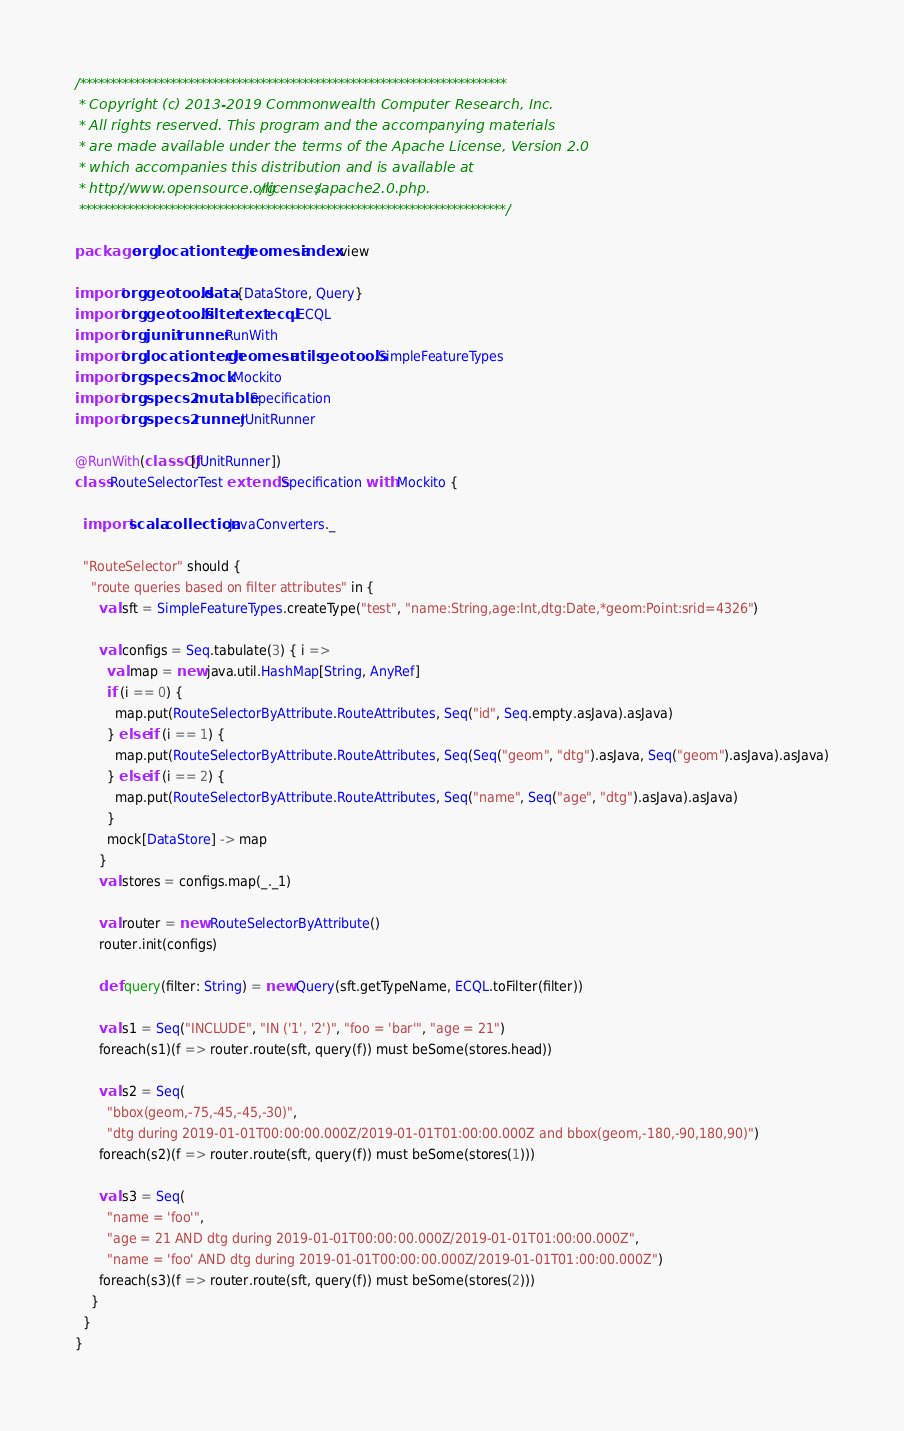<code> <loc_0><loc_0><loc_500><loc_500><_Scala_>/***********************************************************************
 * Copyright (c) 2013-2019 Commonwealth Computer Research, Inc.
 * All rights reserved. This program and the accompanying materials
 * are made available under the terms of the Apache License, Version 2.0
 * which accompanies this distribution and is available at
 * http://www.opensource.org/licenses/apache2.0.php.
 ***********************************************************************/

package org.locationtech.geomesa.index.view

import org.geotools.data.{DataStore, Query}
import org.geotools.filter.text.ecql.ECQL
import org.junit.runner.RunWith
import org.locationtech.geomesa.utils.geotools.SimpleFeatureTypes
import org.specs2.mock.Mockito
import org.specs2.mutable.Specification
import org.specs2.runner.JUnitRunner

@RunWith(classOf[JUnitRunner])
class RouteSelectorTest extends Specification with Mockito {

  import scala.collection.JavaConverters._

  "RouteSelector" should {
    "route queries based on filter attributes" in {
      val sft = SimpleFeatureTypes.createType("test", "name:String,age:Int,dtg:Date,*geom:Point:srid=4326")

      val configs = Seq.tabulate(3) { i =>
        val map = new java.util.HashMap[String, AnyRef]
        if (i == 0) {
          map.put(RouteSelectorByAttribute.RouteAttributes, Seq("id", Seq.empty.asJava).asJava)
        } else if (i == 1) {
          map.put(RouteSelectorByAttribute.RouteAttributes, Seq(Seq("geom", "dtg").asJava, Seq("geom").asJava).asJava)
        } else if (i == 2) {
          map.put(RouteSelectorByAttribute.RouteAttributes, Seq("name", Seq("age", "dtg").asJava).asJava)
        }
        mock[DataStore] -> map
      }
      val stores = configs.map(_._1)

      val router = new RouteSelectorByAttribute()
      router.init(configs)

      def query(filter: String) = new Query(sft.getTypeName, ECQL.toFilter(filter))

      val s1 = Seq("INCLUDE", "IN ('1', '2')", "foo = 'bar'", "age = 21")
      foreach(s1)(f => router.route(sft, query(f)) must beSome(stores.head))

      val s2 = Seq(
        "bbox(geom,-75,-45,-45,-30)",
        "dtg during 2019-01-01T00:00:00.000Z/2019-01-01T01:00:00.000Z and bbox(geom,-180,-90,180,90)")
      foreach(s2)(f => router.route(sft, query(f)) must beSome(stores(1)))

      val s3 = Seq(
        "name = 'foo'",
        "age = 21 AND dtg during 2019-01-01T00:00:00.000Z/2019-01-01T01:00:00.000Z",
        "name = 'foo' AND dtg during 2019-01-01T00:00:00.000Z/2019-01-01T01:00:00.000Z")
      foreach(s3)(f => router.route(sft, query(f)) must beSome(stores(2)))
    }
  }
}
</code> 